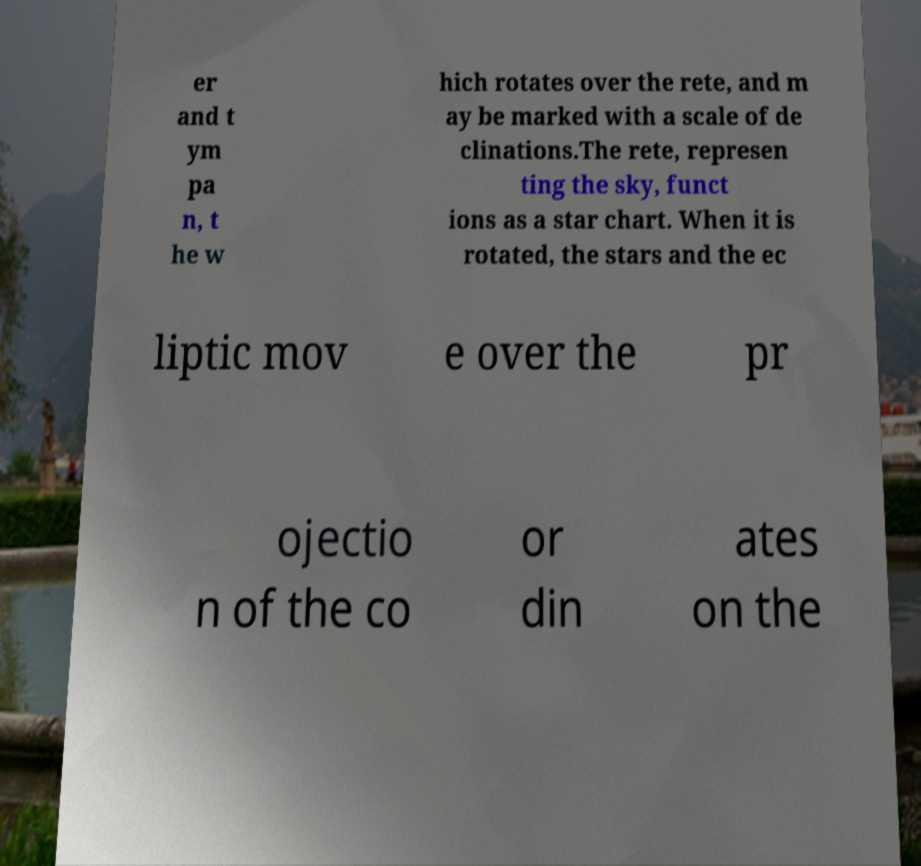Can you accurately transcribe the text from the provided image for me? er and t ym pa n, t he w hich rotates over the rete, and m ay be marked with a scale of de clinations.The rete, represen ting the sky, funct ions as a star chart. When it is rotated, the stars and the ec liptic mov e over the pr ojectio n of the co or din ates on the 